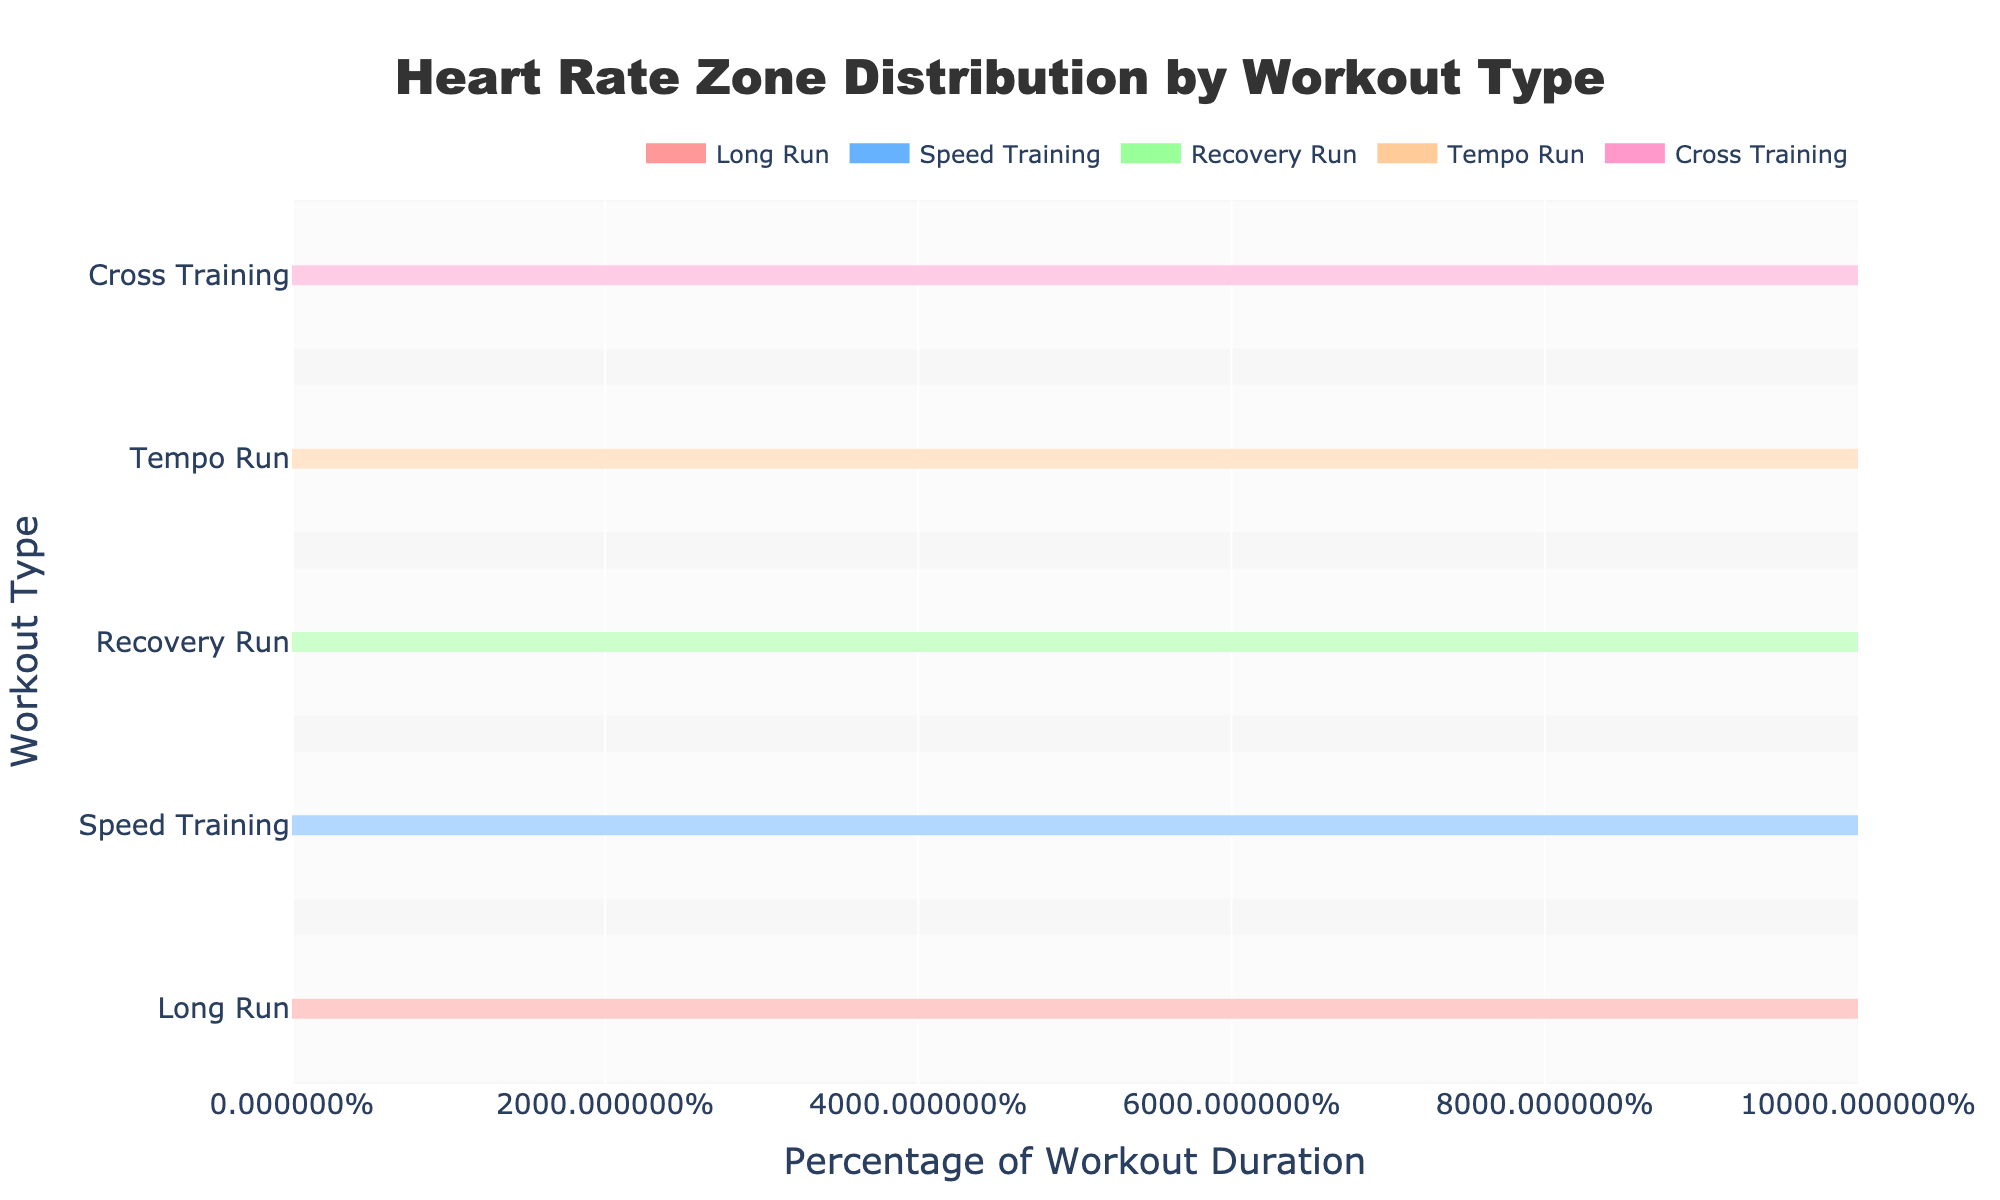What's the title of the figure? The title is displayed prominently at the top of the figure, providing a summary of what the plot represents. The title is "Heart Rate Zone Distribution by Workout Type".
Answer: Heart Rate Zone Distribution by Workout Type Which workout type has the highest percentage in Zone 5? To find this, look for the highest bar segment corresponding to Zone 5 across all workout types. The Speed Training workout type has the longest segment in Zone 5 with 25%.
Answer: Speed Training How much time is spent in Zone 1 during a Recovery Run? Locate the Recovery Run row in the figure and identify the percentage for Zone 1. According to the data, 40% of the time during a Recovery Run is spent in Zone 1.
Answer: 40% Which workout type has the least percentage of time in Zone 3? Compare the length of the Zone 3 bars across different workout types. Cross Training has the smallest segment for Zone 3, at 20%.
Answer: Cross Training Compare the time spent in Zone 4 during Long Run and Tempo Run. Which one is greater? Identify the Zone 4 segments for both Long Run and Tempo Run rows. Long Run has 20% in Zone 4, while Tempo Run has 25%. Hence, Tempo Run has more time in Zone 4.
Answer: Tempo Run What is the total percentage of time spent in Zones 4 and 5 during Speed Training? Add the percentages for Zones 4 and 5 for Speed Training. Zone 4 has 30% and Zone 5 has 25%. The total is 30% + 25% = 55%.
Answer: 55% Which heart rate zone has the highest overall percentage in Recovery Run, and what is the percentage? For Recovery Run, compare the bar lengths for all heart rate zones and identify the highest one. Zone 1 in Recovery Run has the highest percentage at 40%.
Answer: Zone 1, 40% How does the percentage of time spent in Zone 2 during Cross Training compare to that during Tempo Run? Check the Zone 2 percentages for both Cross Training and Tempo Run. Cross Training has 25% in Zone 2, and Tempo Run has 20%. Hence, Cross Training has a greater percentage in Zone 2.
Answer: Cross Training What is the average percentage of time spent in Zone 3 across all workout types? Sum the Zone 3 percentages for all workout types and divide by the number of workout types. For Zone 3: Long Run (30) + Speed Training (20) + Recovery Run (20) + Tempo Run (30) + Cross Training (20) = 120. There are 5 workout types, so 120 / 5 = 24%.
Answer: 24% What is the combined percentage of time spent in Zones 1 and 2 during a Long Run? Add the percentages for Zones 1 and 2 for Long Run. Zone 1 has 15% and Zone 2 has 25%. The total is 15% + 25% = 40%.
Answer: 40% 